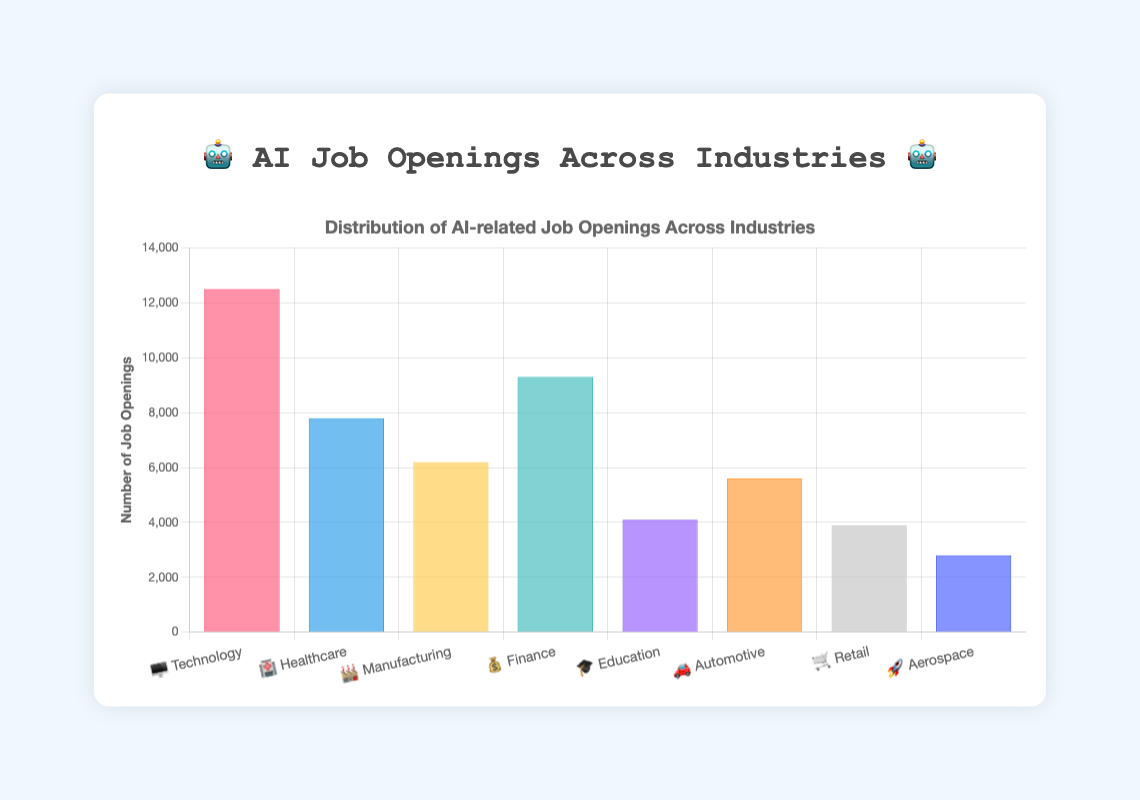How many AI-related job openings are there in the Technology industry? The Technology industry, represented by the 🖥️ emoji, has 12,500 AI-related job openings according to the chart.
Answer: 12,500 AI-related job openings What is the total number of AI-related job openings across all industries? Sum the job openings in all industries: 12,500 (Technology) + 7,800 (Healthcare) + 6,200 (Manufacturing) + 9,300 (Finance) + 4,100 (Education) + 5,600 (Automotive) + 3,900 (Retail) + 2,800 (Aerospace) resulting in 52,200 job openings.
Answer: 52,200 job openings Which industry has the highest number of AI-related job openings? The Technology industry has the highest number of AI-related job openings at 12,500, more than any other industry shown.
Answer: Technology How many more AI-related job openings does Finance have than Retail? Finance has 9,300 openings while Retail has 3,900. Subtract Retail from Finance: 9,300 - 3,900 = 5,400 more openings.
Answer: 5,400 more openings Rank the industries from highest to lowest in terms of AI-related job openings. Arrange the industries based on job openings: Technology (12,500), Finance (9,300), Healthcare (7,800), Manufacturing (6,200), Automotive (5,600), Education (4,100), Retail (3,900), and Aerospace (2,800).
Answer: Technology, Finance, Healthcare, Manufacturing, Automotive, Education, Retail, Aerospace Which industry has fewer than 5,000 AI-related job openings? Identify industries with job openings below 5,000: Education (4,100), Retail (3,900), and Aerospace (2,800).
Answer: Education, Retail, Aerospace How many industries have more than 6,000 but fewer than 10,000 AI-related job openings? Count industries within this range: Healthcare (7,800), Manufacturing (6,200), Finance (9,300). Three industries meet this criterion.
Answer: Three industries What is the combined number of AI job openings for Education, Retail, and Aerospace? Add the job openings: Education (4,100) + Retail (3,900) + Aerospace (2,800) equals 10,800.
Answer: 10,800 job openings How does Automotive's AI job openings compare to Manufacturing's? Automotive has 5,600 job openings, while Manufacturing has 6,200, indicating Automotive has fewer openings than Manufacturing.
Answer: Fewer openings 